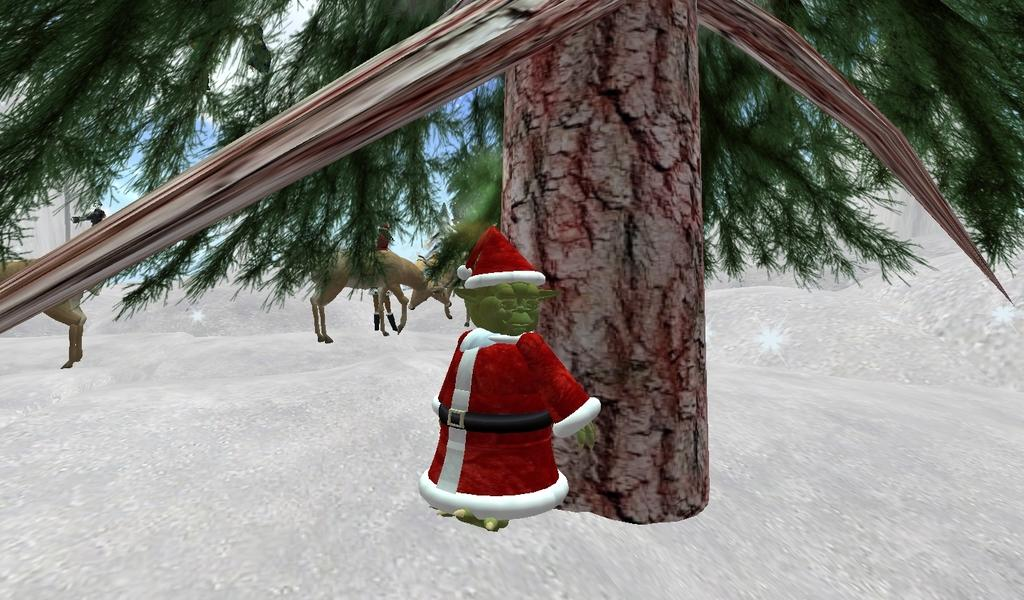What type of image is being described? The image is animated. What natural element can be seen in the image? There is a tree in the image. What is unique about one of the animals in the image? There is an animal wearing a red dress in the image. What can be observed in the background of the image? There are other animals in the background of the image. What type of trade is being conducted by the father in the image? There is no father present in the image, and therefore no trade can be observed. 